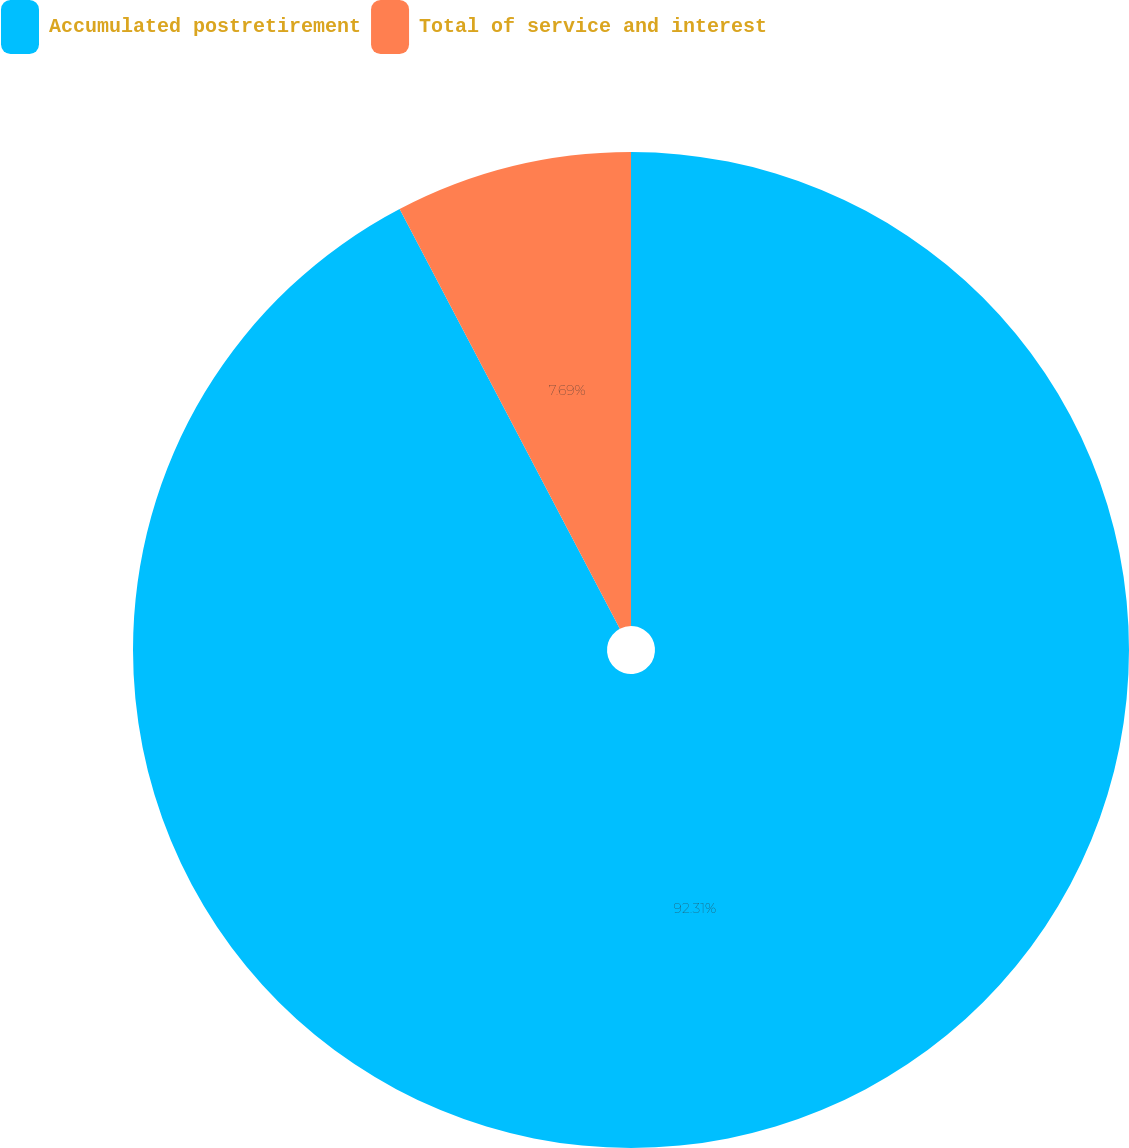Convert chart to OTSL. <chart><loc_0><loc_0><loc_500><loc_500><pie_chart><fcel>Accumulated postretirement<fcel>Total of service and interest<nl><fcel>92.31%<fcel>7.69%<nl></chart> 